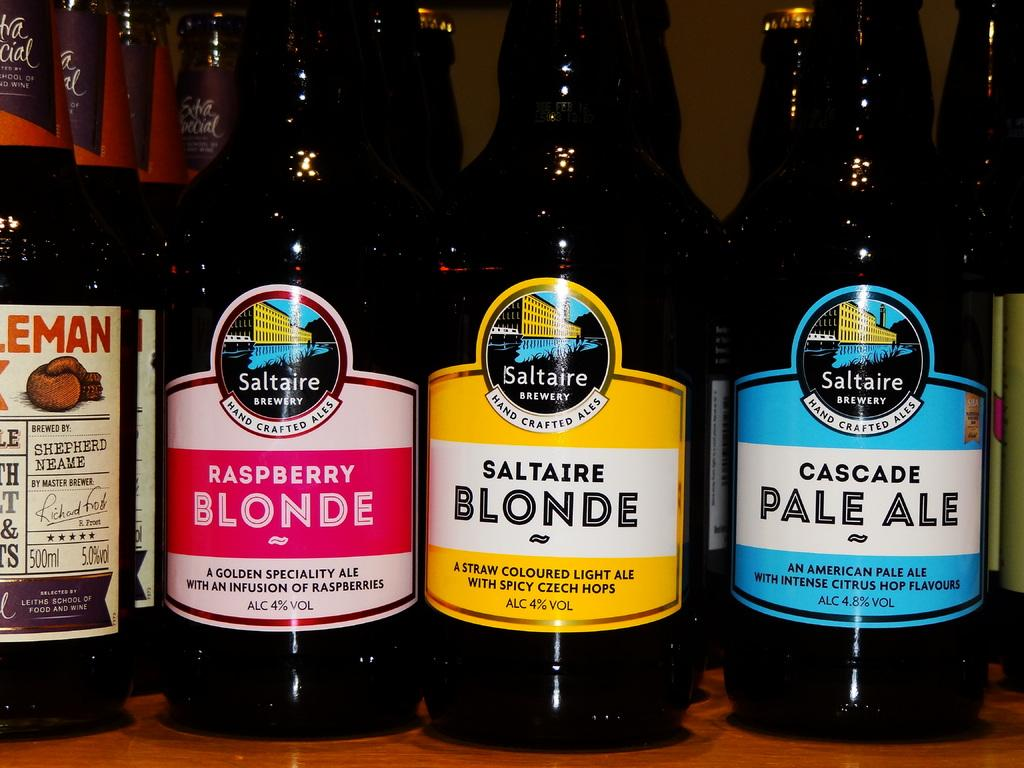<image>
Share a concise interpretation of the image provided. a variety of blonde beer bottles including cascade pale ale 